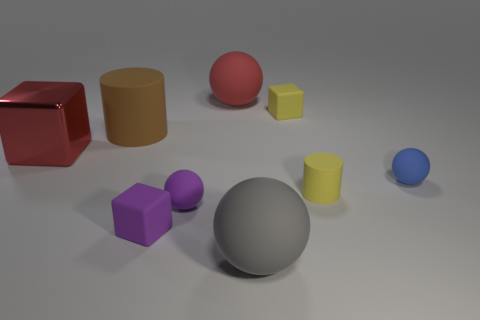What number of other objects are the same color as the tiny rubber cylinder?
Make the answer very short. 1. Is there any other thing that has the same size as the red metal cube?
Your answer should be compact. Yes. How many things are either large brown things or objects behind the purple matte cube?
Your answer should be compact. 7. There is a yellow cylinder that is the same material as the gray ball; what is its size?
Ensure brevity in your answer.  Small. What shape is the large red thing that is on the left side of the tiny matte ball to the left of the large gray ball?
Your response must be concise. Cube. There is a thing that is both on the left side of the gray rubber sphere and behind the big brown rubber thing; what size is it?
Offer a terse response. Large. Is there another object that has the same shape as the red rubber object?
Provide a short and direct response. Yes. Is there any other thing that has the same shape as the red shiny thing?
Ensure brevity in your answer.  Yes. What is the material of the large ball that is behind the small ball that is to the right of the yellow matte thing in front of the metal thing?
Ensure brevity in your answer.  Rubber. Is there a cyan metallic object that has the same size as the red metallic block?
Your answer should be very brief. No. 